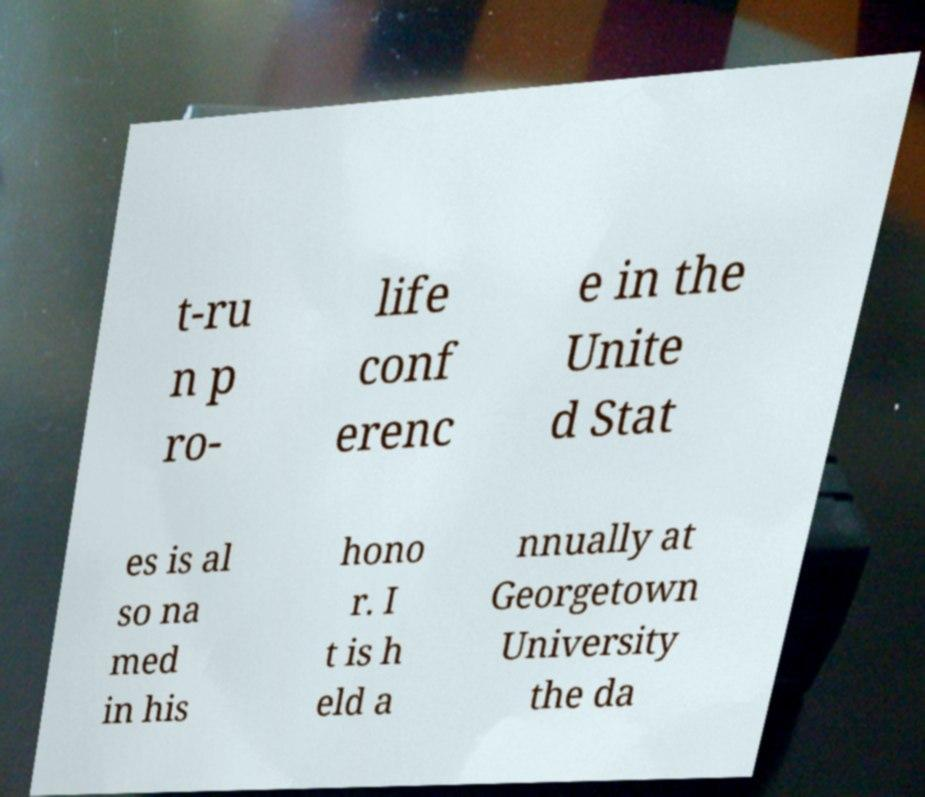Please read and relay the text visible in this image. What does it say? t-ru n p ro- life conf erenc e in the Unite d Stat es is al so na med in his hono r. I t is h eld a nnually at Georgetown University the da 